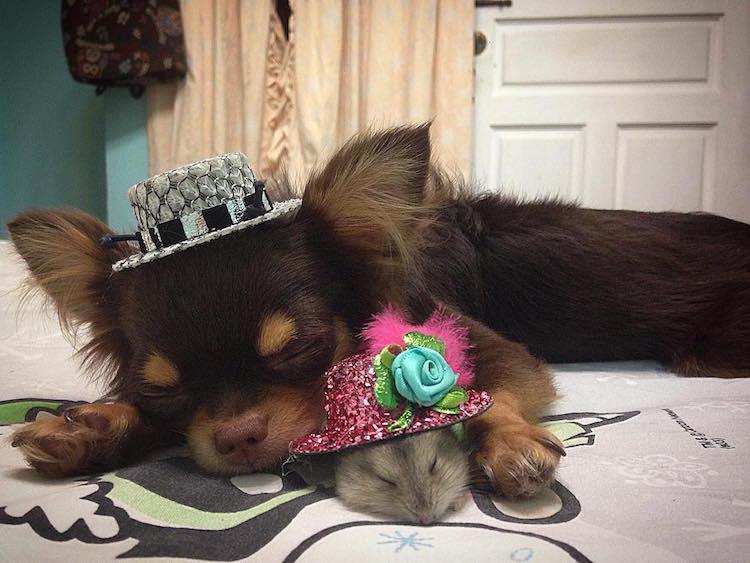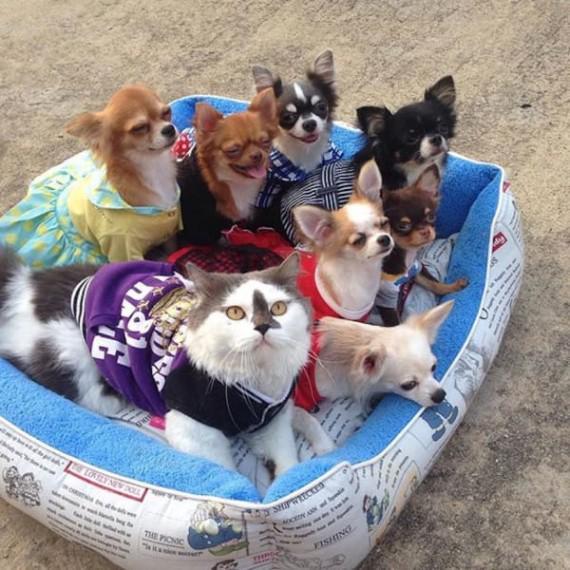The first image is the image on the left, the second image is the image on the right. Assess this claim about the two images: "The sleeping cat is snuggling with a dog in the image on the right.". Correct or not? Answer yes or no. No. 